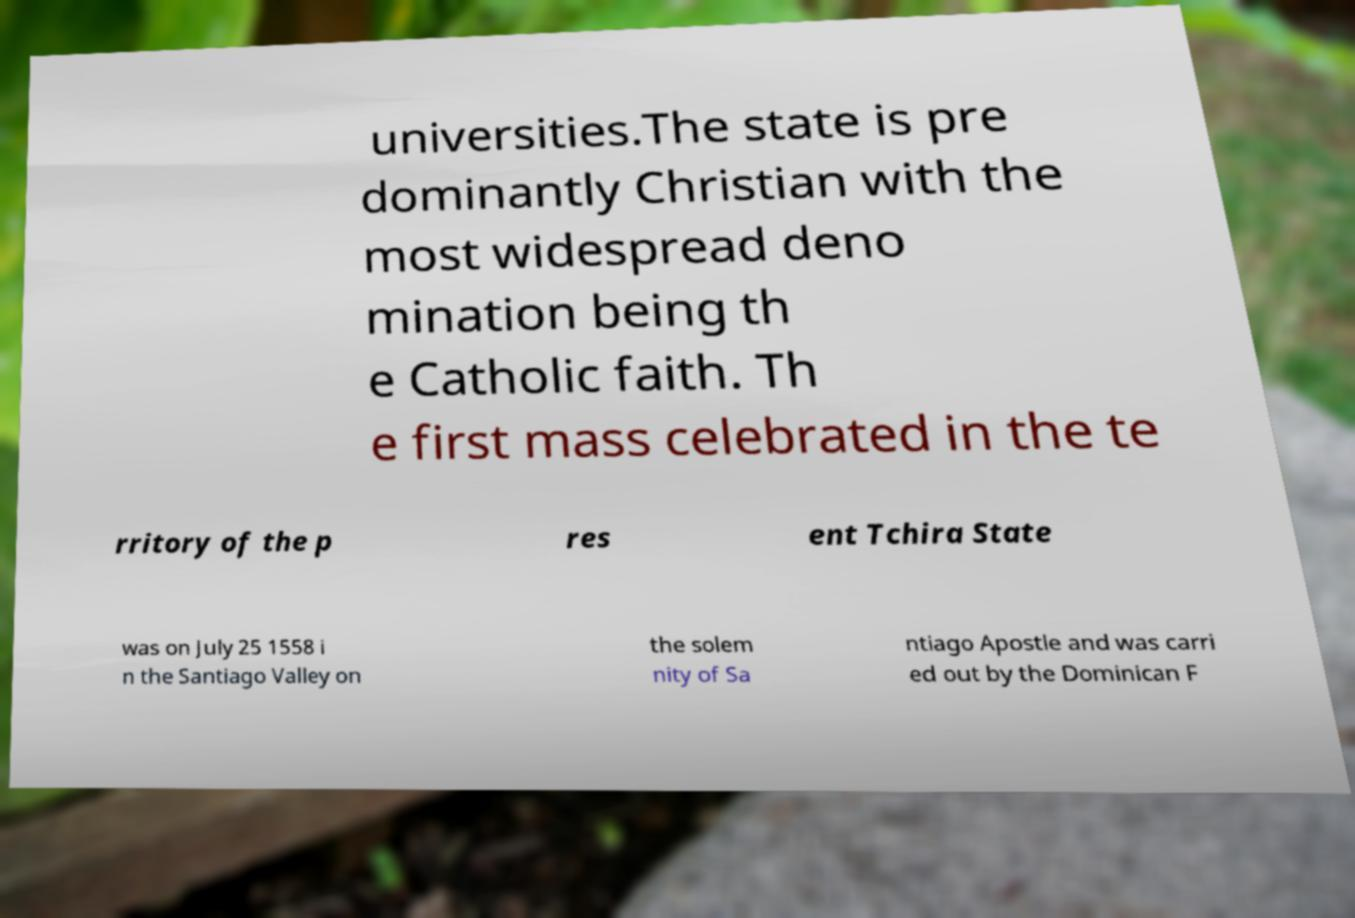For documentation purposes, I need the text within this image transcribed. Could you provide that? universities.The state is pre dominantly Christian with the most widespread deno mination being th e Catholic faith. Th e first mass celebrated in the te rritory of the p res ent Tchira State was on July 25 1558 i n the Santiago Valley on the solem nity of Sa ntiago Apostle and was carri ed out by the Dominican F 